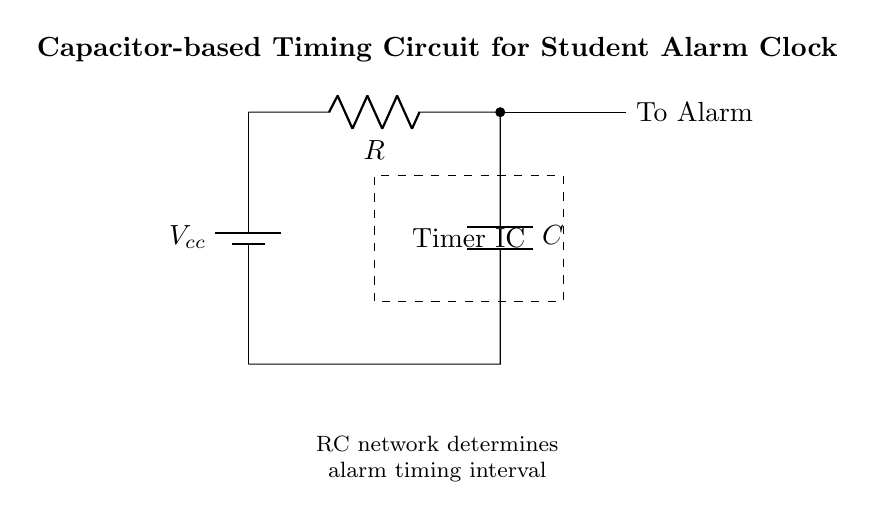What type of capacitor is used in the circuit? The diagram indicates a general capacitor symbol, which in this context represents a non-polarized capacitor used in timing applications.
Answer: non-polarized What does the resistor control in this circuit? The resistor in the circuit affects the charge and discharge rate of the capacitor, influencing the timing interval for the alarm.
Answer: timing interval What is the purpose of the Timer IC in the diagram? The Timer IC is responsible for generating a precise timing signal based on the RC network, triggering the alarm at the specified interval.
Answer: generate timing signal What happens to the capacitor when it's charged? When the capacitor is charged, it stores electrical energy, and the voltage across the capacitor increases to the supply voltage level until it reaches a predetermined threshold.
Answer: stores energy How does changing the value of the resistor affect the timing? Increasing the resistance will slow down the charging and discharging time of the capacitor, leading to a longer timing interval, while decreasing the resistance will have the opposite effect.
Answer: lengthens timing interval What is the role of the voltage source in this circuit? The voltage source provides the necessary power for the circuit to function, allowing current to flow through the resistor and capacitor, as well as powering the Timer IC.
Answer: power source 